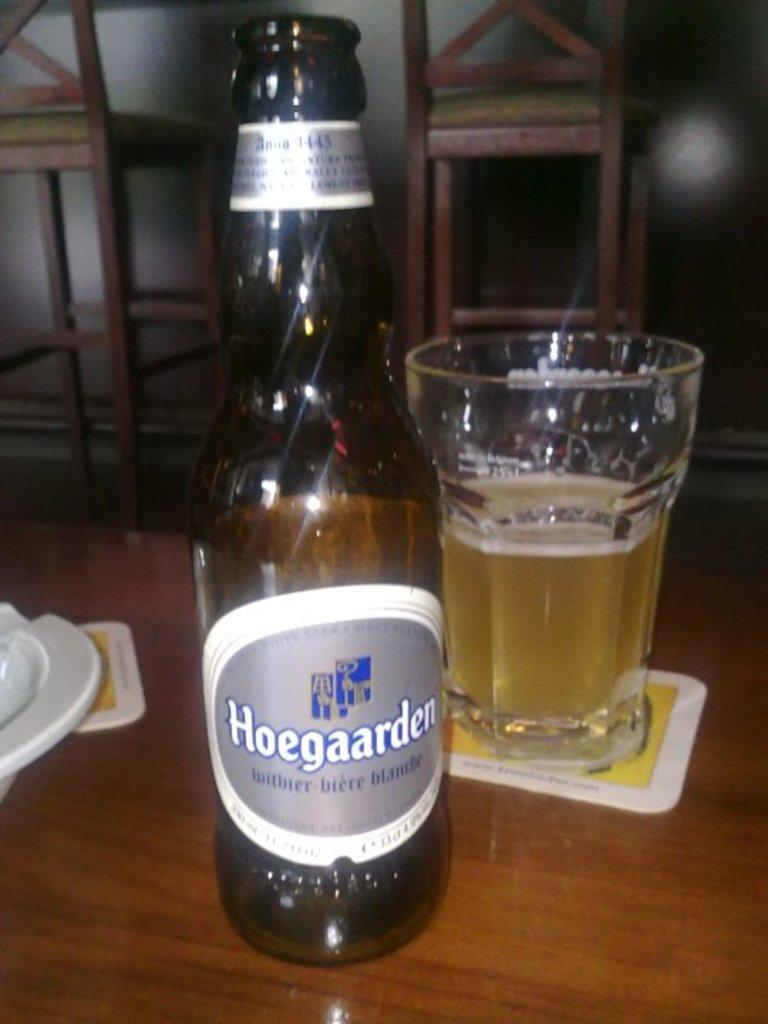Provide a one-sentence caption for the provided image. A bottle of Hoegaarden beer sits next to a half full glass. 